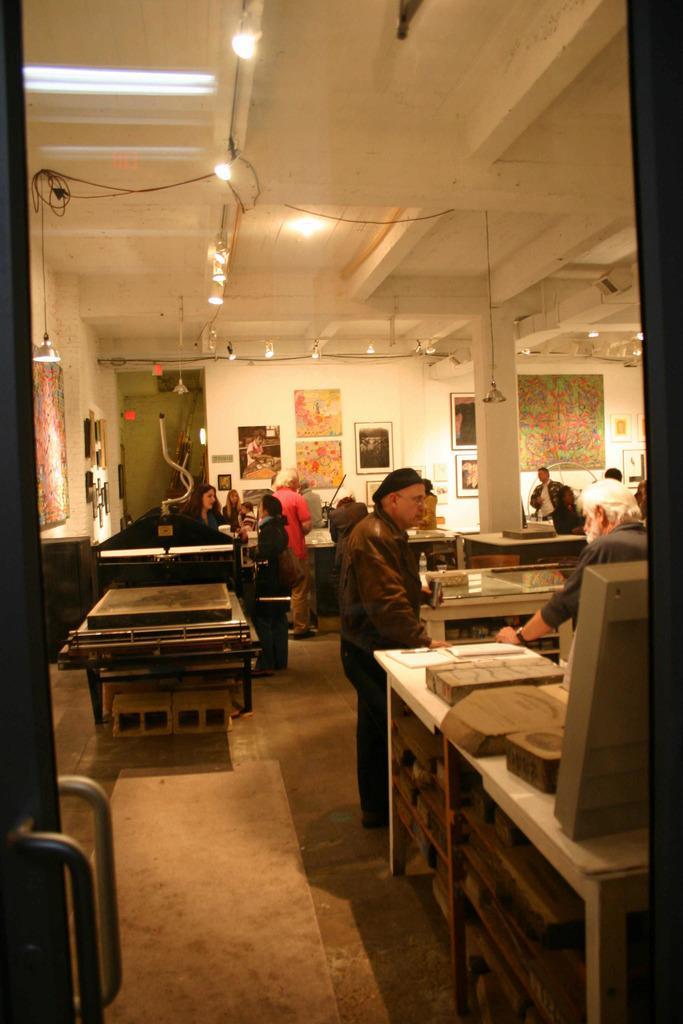Can you describe this image briefly? In this picture i could see some persons standing near the table and watching to the scriptures which are displayed on the table. In the back ground i could see some picture frames on the wall, and on the ceiling there are some flash lights. To the left there is a door with the holder. 